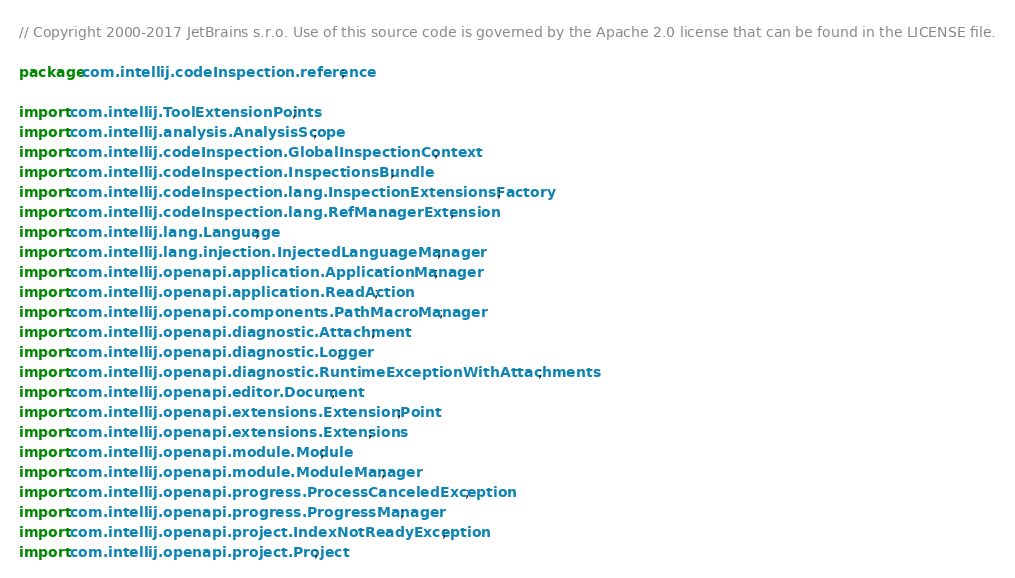Convert code to text. <code><loc_0><loc_0><loc_500><loc_500><_Java_>// Copyright 2000-2017 JetBrains s.r.o. Use of this source code is governed by the Apache 2.0 license that can be found in the LICENSE file.

package com.intellij.codeInspection.reference;

import com.intellij.ToolExtensionPoints;
import com.intellij.analysis.AnalysisScope;
import com.intellij.codeInspection.GlobalInspectionContext;
import com.intellij.codeInspection.InspectionsBundle;
import com.intellij.codeInspection.lang.InspectionExtensionsFactory;
import com.intellij.codeInspection.lang.RefManagerExtension;
import com.intellij.lang.Language;
import com.intellij.lang.injection.InjectedLanguageManager;
import com.intellij.openapi.application.ApplicationManager;
import com.intellij.openapi.application.ReadAction;
import com.intellij.openapi.components.PathMacroManager;
import com.intellij.openapi.diagnostic.Attachment;
import com.intellij.openapi.diagnostic.Logger;
import com.intellij.openapi.diagnostic.RuntimeExceptionWithAttachments;
import com.intellij.openapi.editor.Document;
import com.intellij.openapi.extensions.ExtensionPoint;
import com.intellij.openapi.extensions.Extensions;
import com.intellij.openapi.module.Module;
import com.intellij.openapi.module.ModuleManager;
import com.intellij.openapi.progress.ProcessCanceledException;
import com.intellij.openapi.progress.ProgressManager;
import com.intellij.openapi.project.IndexNotReadyException;
import com.intellij.openapi.project.Project;</code> 